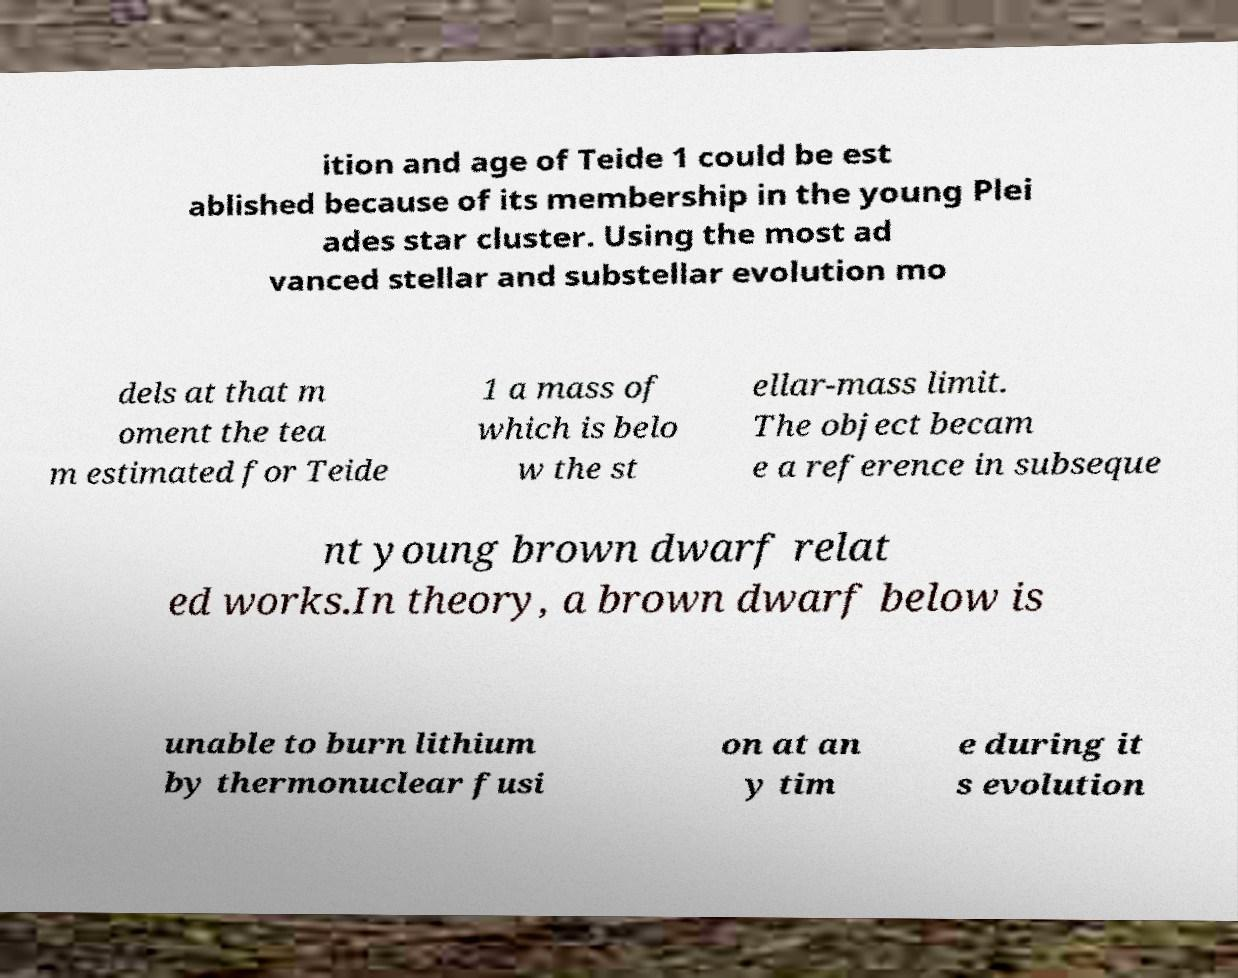What messages or text are displayed in this image? I need them in a readable, typed format. ition and age of Teide 1 could be est ablished because of its membership in the young Plei ades star cluster. Using the most ad vanced stellar and substellar evolution mo dels at that m oment the tea m estimated for Teide 1 a mass of which is belo w the st ellar-mass limit. The object becam e a reference in subseque nt young brown dwarf relat ed works.In theory, a brown dwarf below is unable to burn lithium by thermonuclear fusi on at an y tim e during it s evolution 